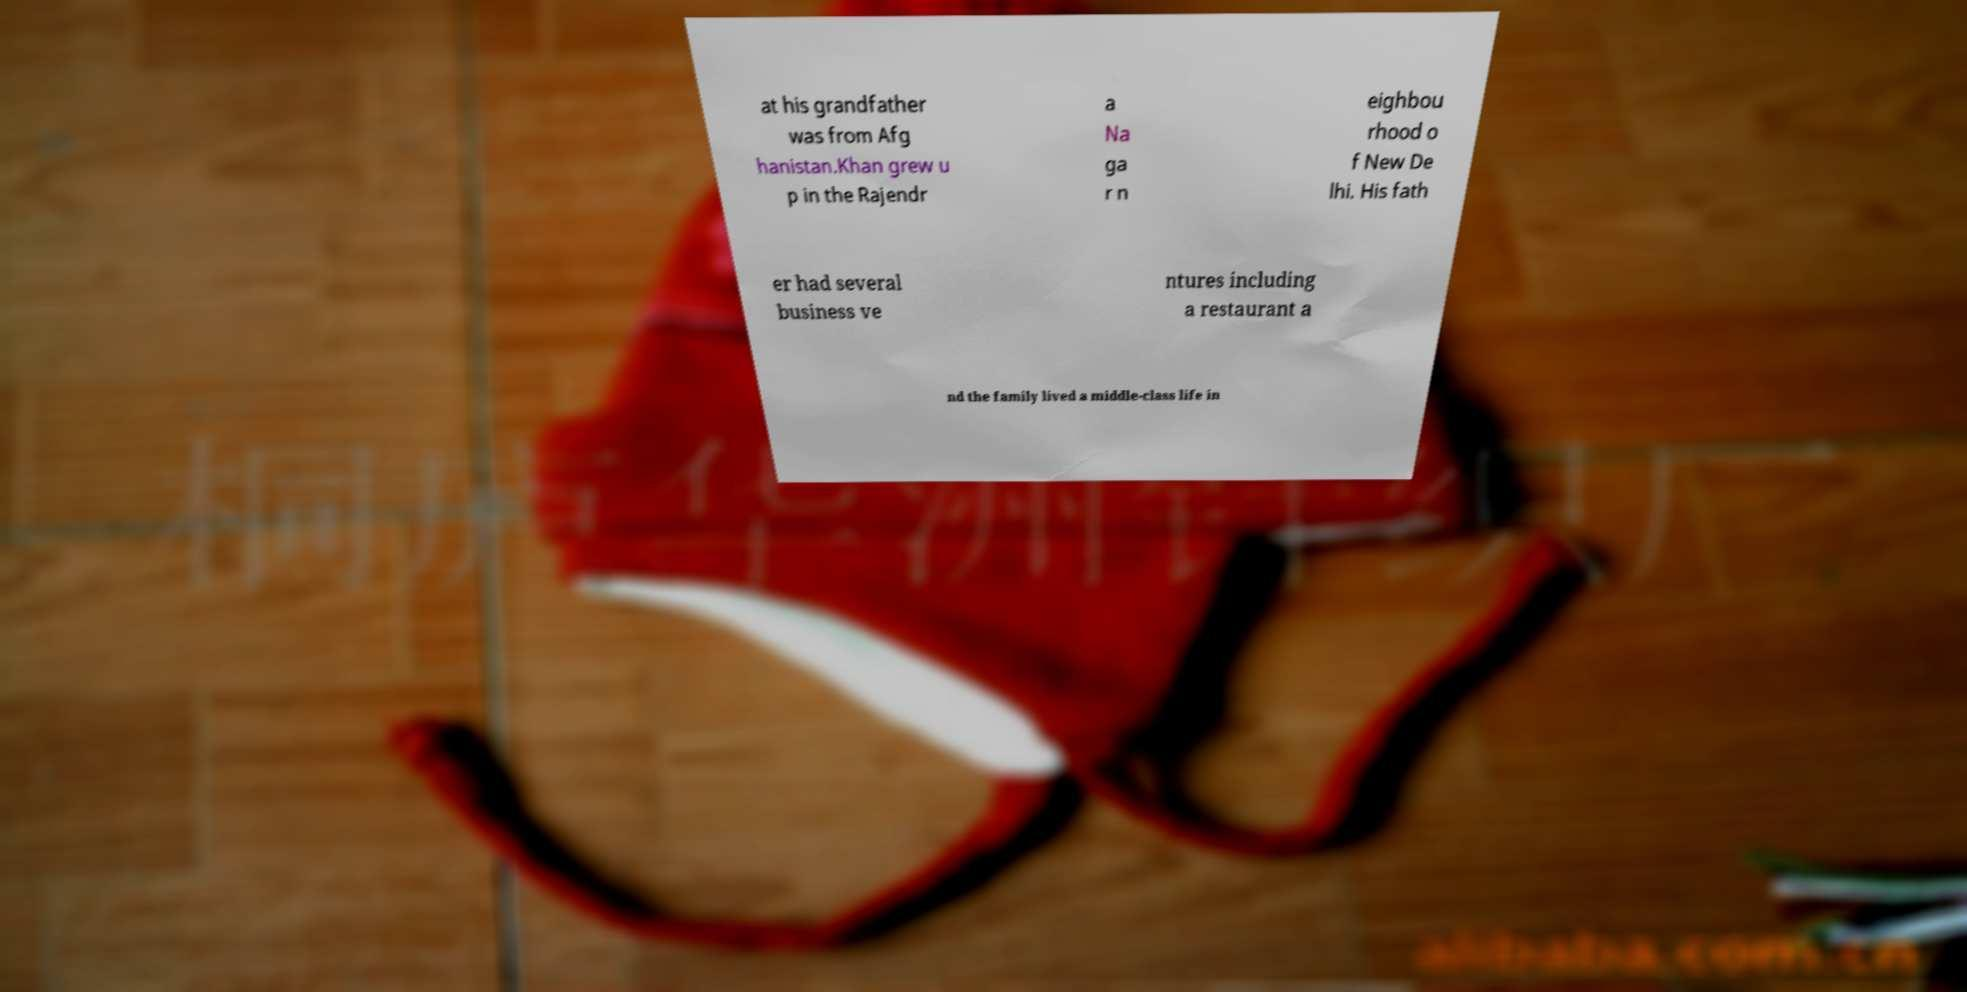For documentation purposes, I need the text within this image transcribed. Could you provide that? at his grandfather was from Afg hanistan.Khan grew u p in the Rajendr a Na ga r n eighbou rhood o f New De lhi. His fath er had several business ve ntures including a restaurant a nd the family lived a middle-class life in 